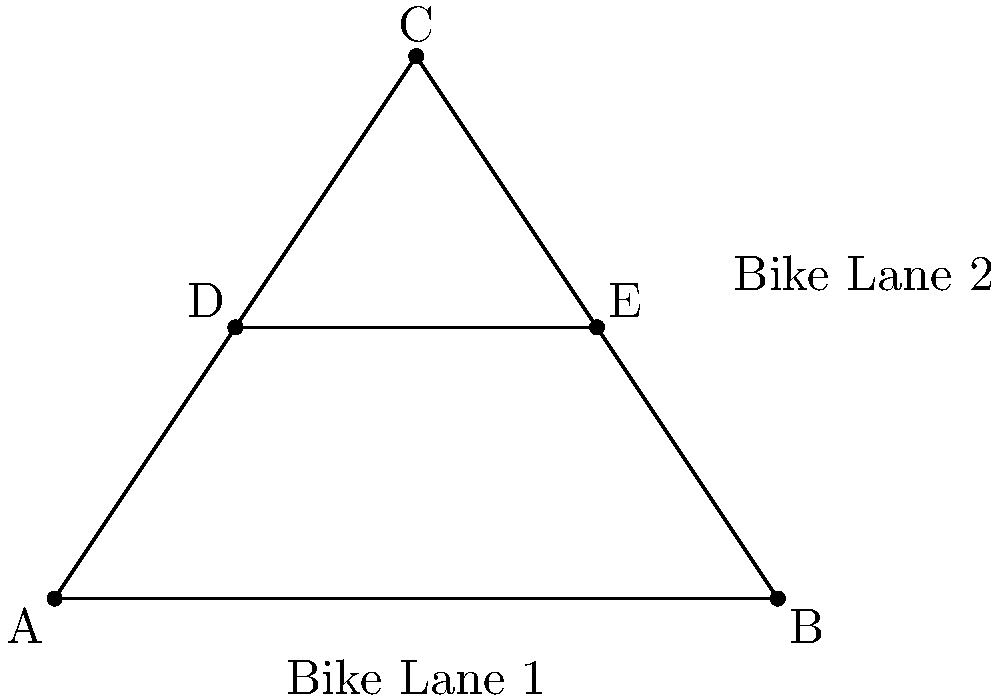In a new eco-friendly transportation network, three bike lanes form a triangle ABC, with coordinates A(0,0), B(8,0), and C(4,6). A fourth bike lane DE intersects this triangle, with D(2,3) and E(6,3). How many intersection points are there between all these bike lanes, and what is the area of triangle ABC in square units? To solve this problem, we need to follow these steps:

1. Count the intersection points:
   a) DE intersects AC at one point
   b) DE intersects BC at one point
   c) AB, BC, and AC intersect at three points (the vertices of the triangle)
   Total intersection points: 2 + 3 = 5

2. Calculate the area of triangle ABC:
   a) Use the formula: Area = $\frac{1}{2}|x_1(y_2 - y_3) + x_2(y_3 - y_1) + x_3(y_1 - y_2)|$
   b) Substitute the coordinates:
      $A(0,0)$, $B(8,0)$, $C(4,6)$
   c) Calculate:
      Area = $\frac{1}{2}|0(0 - 6) + 8(6 - 0) + 4(0 - 0)|$
           = $\frac{1}{2}|0 + 48 + 0|$
           = $\frac{1}{2}(48)$
           = 24 square units

Therefore, there are 5 intersection points, and the area of triangle ABC is 24 square units.
Answer: 5 intersection points; 24 square units 